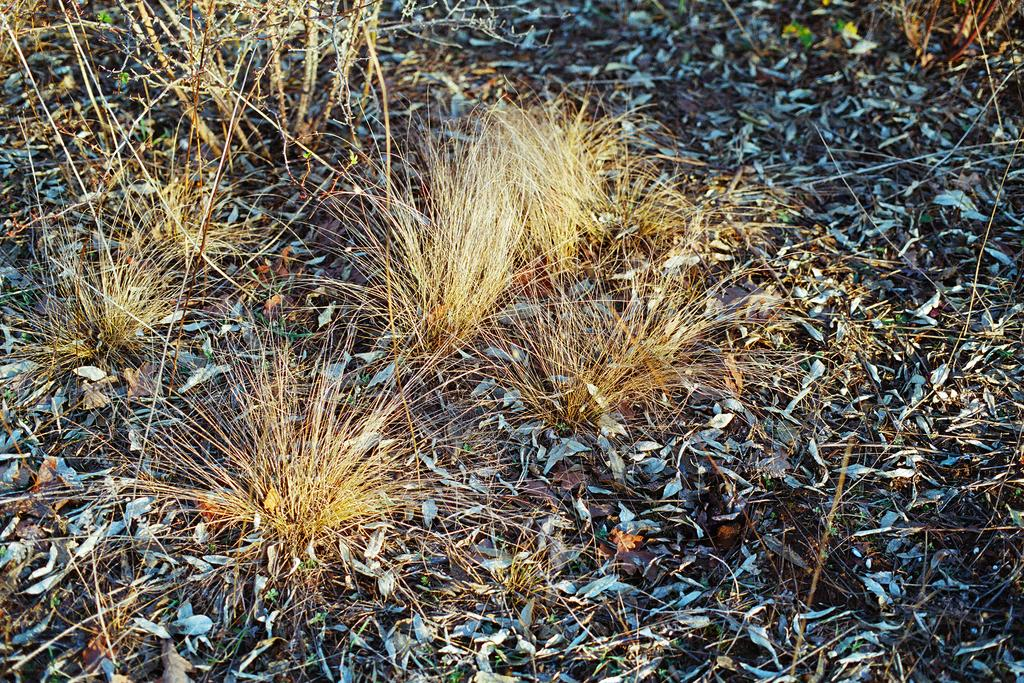Where was the image taken? The image is taken outdoors. What type of surface is visible in the image? There is a ground with grass in the image. What can be found on the ground in the image? There are dry leaves on the ground. What type of vegetation is present in the image? There are plants with stems in the image. What type of stove can be seen in the image? There is no stove present in the image. What day of the week is it in the image? The image does not provide information about the day of the week. 